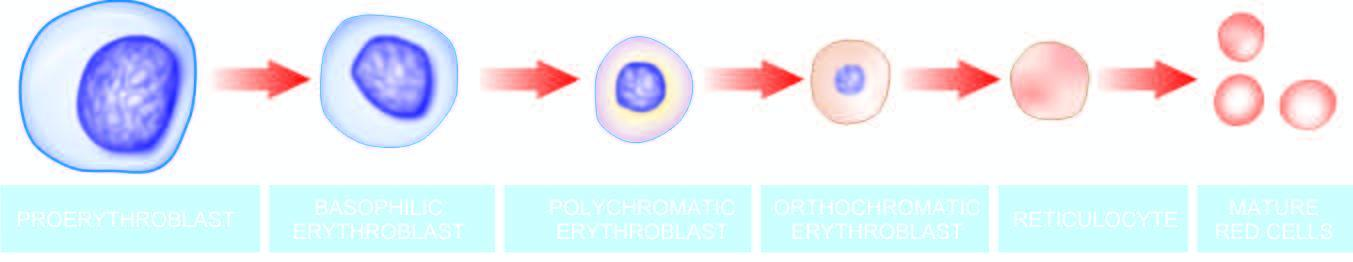s there progressive condensation of the nuclear chromatin which is eventually extruded from the cell at the late erythroblast stage?
Answer the question using a single word or phrase. Yes 